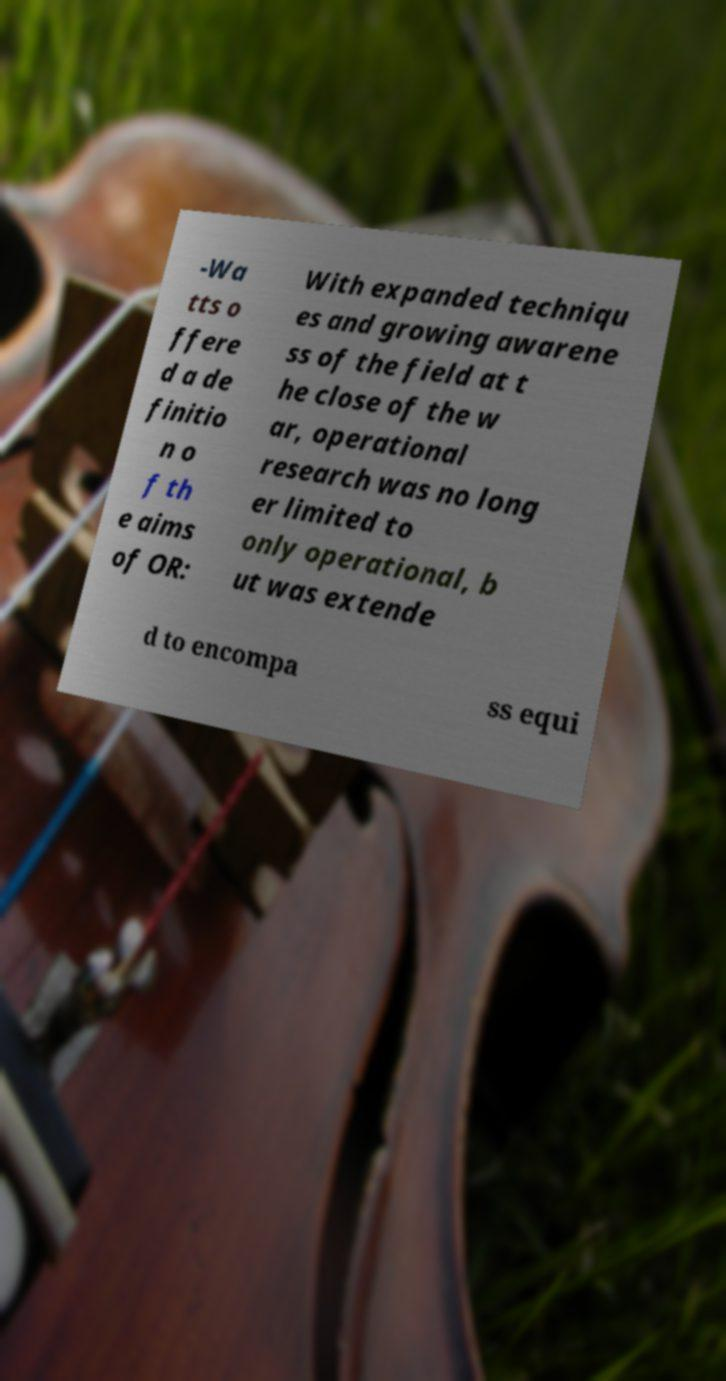What messages or text are displayed in this image? I need them in a readable, typed format. -Wa tts o ffere d a de finitio n o f th e aims of OR: With expanded techniqu es and growing awarene ss of the field at t he close of the w ar, operational research was no long er limited to only operational, b ut was extende d to encompa ss equi 